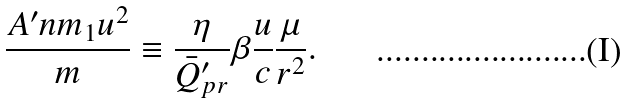Convert formula to latex. <formula><loc_0><loc_0><loc_500><loc_500>\frac { A ^ { \prime } n m _ { 1 } u ^ { 2 } } { m } \equiv \frac { \eta } { \bar { Q } ^ { \prime } _ { p r } } \beta \frac { u } { c } \frac { \mu } { r ^ { 2 } } .</formula> 